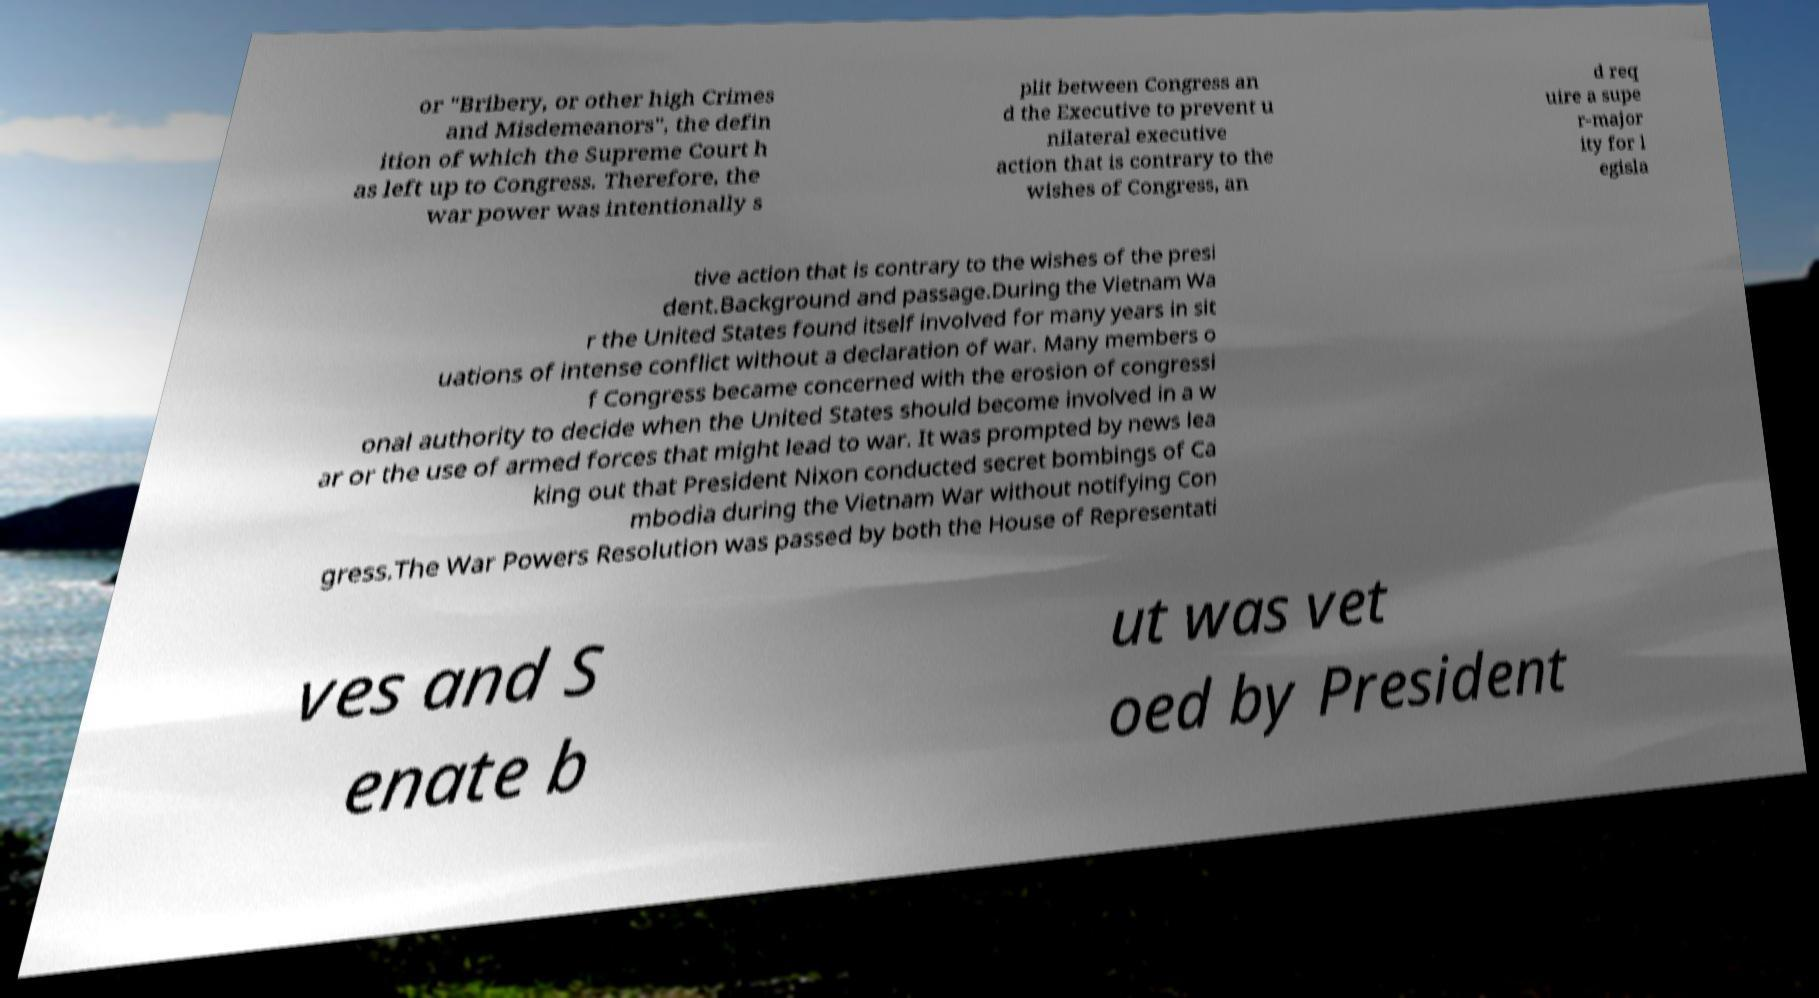Could you assist in decoding the text presented in this image and type it out clearly? or "Bribery, or other high Crimes and Misdemeanors", the defin ition of which the Supreme Court h as left up to Congress. Therefore, the war power was intentionally s plit between Congress an d the Executive to prevent u nilateral executive action that is contrary to the wishes of Congress, an d req uire a supe r-major ity for l egisla tive action that is contrary to the wishes of the presi dent.Background and passage.During the Vietnam Wa r the United States found itself involved for many years in sit uations of intense conflict without a declaration of war. Many members o f Congress became concerned with the erosion of congressi onal authority to decide when the United States should become involved in a w ar or the use of armed forces that might lead to war. It was prompted by news lea king out that President Nixon conducted secret bombings of Ca mbodia during the Vietnam War without notifying Con gress.The War Powers Resolution was passed by both the House of Representati ves and S enate b ut was vet oed by President 